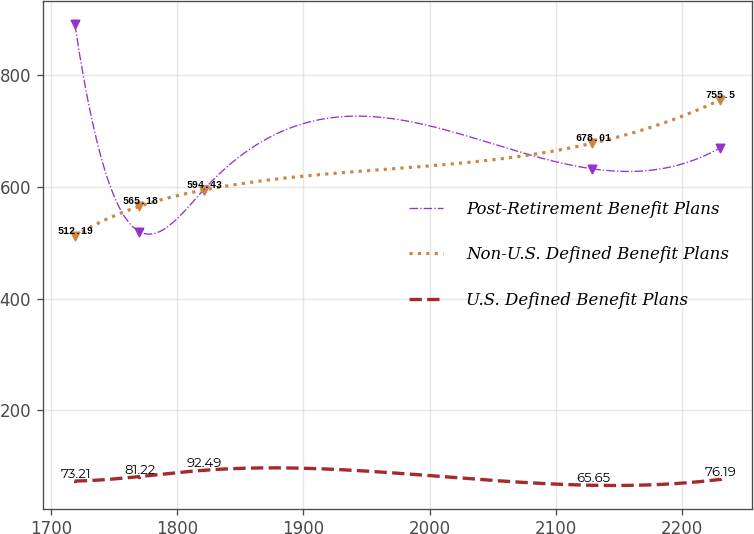<chart> <loc_0><loc_0><loc_500><loc_500><line_chart><ecel><fcel>Post-Retirement Benefit Plans<fcel>Non-U.S. Defined Benefit Plans<fcel>U.S. Defined Benefit Plans<nl><fcel>1718.66<fcel>891.84<fcel>512.19<fcel>73.21<nl><fcel>1769.83<fcel>519.93<fcel>565.18<fcel>81.22<nl><fcel>1821<fcel>595.19<fcel>594.43<fcel>92.49<nl><fcel>2129.01<fcel>632.38<fcel>678.01<fcel>65.65<nl><fcel>2230.33<fcel>669.57<fcel>755.5<fcel>76.19<nl></chart> 